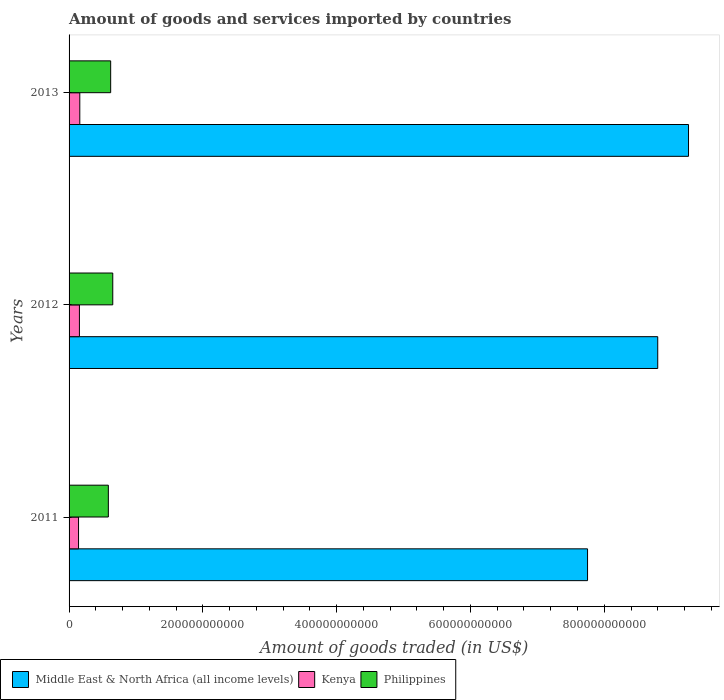How many different coloured bars are there?
Your response must be concise. 3. How many bars are there on the 3rd tick from the bottom?
Your answer should be very brief. 3. What is the label of the 3rd group of bars from the top?
Give a very brief answer. 2011. In how many cases, is the number of bars for a given year not equal to the number of legend labels?
Your answer should be very brief. 0. What is the total amount of goods and services imported in Philippines in 2011?
Provide a succinct answer. 5.87e+1. Across all years, what is the maximum total amount of goods and services imported in Middle East & North Africa (all income levels)?
Your answer should be compact. 9.26e+11. Across all years, what is the minimum total amount of goods and services imported in Kenya?
Provide a succinct answer. 1.42e+1. In which year was the total amount of goods and services imported in Kenya maximum?
Your response must be concise. 2013. What is the total total amount of goods and services imported in Kenya in the graph?
Offer a very short reply. 4.57e+1. What is the difference between the total amount of goods and services imported in Kenya in 2011 and that in 2012?
Make the answer very short. -1.31e+09. What is the difference between the total amount of goods and services imported in Philippines in 2011 and the total amount of goods and services imported in Kenya in 2013?
Offer a terse response. 4.27e+1. What is the average total amount of goods and services imported in Kenya per year?
Your response must be concise. 1.52e+1. In the year 2013, what is the difference between the total amount of goods and services imported in Middle East & North Africa (all income levels) and total amount of goods and services imported in Kenya?
Offer a terse response. 9.10e+11. In how many years, is the total amount of goods and services imported in Middle East & North Africa (all income levels) greater than 720000000000 US$?
Your response must be concise. 3. What is the ratio of the total amount of goods and services imported in Kenya in 2011 to that in 2013?
Offer a very short reply. 0.88. Is the difference between the total amount of goods and services imported in Middle East & North Africa (all income levels) in 2012 and 2013 greater than the difference between the total amount of goods and services imported in Kenya in 2012 and 2013?
Make the answer very short. No. What is the difference between the highest and the second highest total amount of goods and services imported in Middle East & North Africa (all income levels)?
Provide a succinct answer. 4.60e+1. What is the difference between the highest and the lowest total amount of goods and services imported in Middle East & North Africa (all income levels)?
Give a very brief answer. 1.51e+11. Is the sum of the total amount of goods and services imported in Middle East & North Africa (all income levels) in 2012 and 2013 greater than the maximum total amount of goods and services imported in Kenya across all years?
Provide a short and direct response. Yes. What does the 2nd bar from the bottom in 2013 represents?
Offer a terse response. Kenya. How many years are there in the graph?
Make the answer very short. 3. What is the difference between two consecutive major ticks on the X-axis?
Offer a very short reply. 2.00e+11. Does the graph contain grids?
Your answer should be very brief. No. Where does the legend appear in the graph?
Ensure brevity in your answer.  Bottom left. How many legend labels are there?
Keep it short and to the point. 3. How are the legend labels stacked?
Your response must be concise. Horizontal. What is the title of the graph?
Provide a short and direct response. Amount of goods and services imported by countries. Does "Kuwait" appear as one of the legend labels in the graph?
Provide a short and direct response. No. What is the label or title of the X-axis?
Give a very brief answer. Amount of goods traded (in US$). What is the Amount of goods traded (in US$) in Middle East & North Africa (all income levels) in 2011?
Offer a very short reply. 7.75e+11. What is the Amount of goods traded (in US$) of Kenya in 2011?
Your response must be concise. 1.42e+1. What is the Amount of goods traded (in US$) in Philippines in 2011?
Provide a succinct answer. 5.87e+1. What is the Amount of goods traded (in US$) in Middle East & North Africa (all income levels) in 2012?
Provide a succinct answer. 8.80e+11. What is the Amount of goods traded (in US$) of Kenya in 2012?
Your answer should be compact. 1.55e+1. What is the Amount of goods traded (in US$) in Philippines in 2012?
Provide a succinct answer. 6.53e+1. What is the Amount of goods traded (in US$) in Middle East & North Africa (all income levels) in 2013?
Keep it short and to the point. 9.26e+11. What is the Amount of goods traded (in US$) in Kenya in 2013?
Offer a terse response. 1.60e+1. What is the Amount of goods traded (in US$) of Philippines in 2013?
Offer a terse response. 6.22e+1. Across all years, what is the maximum Amount of goods traded (in US$) of Middle East & North Africa (all income levels)?
Give a very brief answer. 9.26e+11. Across all years, what is the maximum Amount of goods traded (in US$) of Kenya?
Keep it short and to the point. 1.60e+1. Across all years, what is the maximum Amount of goods traded (in US$) in Philippines?
Offer a very short reply. 6.53e+1. Across all years, what is the minimum Amount of goods traded (in US$) of Middle East & North Africa (all income levels)?
Make the answer very short. 7.75e+11. Across all years, what is the minimum Amount of goods traded (in US$) in Kenya?
Ensure brevity in your answer.  1.42e+1. Across all years, what is the minimum Amount of goods traded (in US$) of Philippines?
Your response must be concise. 5.87e+1. What is the total Amount of goods traded (in US$) of Middle East & North Africa (all income levels) in the graph?
Provide a short and direct response. 2.58e+12. What is the total Amount of goods traded (in US$) of Kenya in the graph?
Provide a short and direct response. 4.57e+1. What is the total Amount of goods traded (in US$) in Philippines in the graph?
Provide a succinct answer. 1.86e+11. What is the difference between the Amount of goods traded (in US$) of Middle East & North Africa (all income levels) in 2011 and that in 2012?
Provide a succinct answer. -1.05e+11. What is the difference between the Amount of goods traded (in US$) of Kenya in 2011 and that in 2012?
Your answer should be very brief. -1.31e+09. What is the difference between the Amount of goods traded (in US$) in Philippines in 2011 and that in 2012?
Offer a terse response. -6.61e+09. What is the difference between the Amount of goods traded (in US$) in Middle East & North Africa (all income levels) in 2011 and that in 2013?
Offer a terse response. -1.51e+11. What is the difference between the Amount of goods traded (in US$) in Kenya in 2011 and that in 2013?
Give a very brief answer. -1.86e+09. What is the difference between the Amount of goods traded (in US$) in Philippines in 2011 and that in 2013?
Your answer should be very brief. -3.47e+09. What is the difference between the Amount of goods traded (in US$) in Middle East & North Africa (all income levels) in 2012 and that in 2013?
Keep it short and to the point. -4.60e+1. What is the difference between the Amount of goods traded (in US$) of Kenya in 2012 and that in 2013?
Ensure brevity in your answer.  -5.52e+08. What is the difference between the Amount of goods traded (in US$) of Philippines in 2012 and that in 2013?
Make the answer very short. 3.14e+09. What is the difference between the Amount of goods traded (in US$) of Middle East & North Africa (all income levels) in 2011 and the Amount of goods traded (in US$) of Kenya in 2012?
Give a very brief answer. 7.60e+11. What is the difference between the Amount of goods traded (in US$) in Middle East & North Africa (all income levels) in 2011 and the Amount of goods traded (in US$) in Philippines in 2012?
Provide a short and direct response. 7.10e+11. What is the difference between the Amount of goods traded (in US$) of Kenya in 2011 and the Amount of goods traded (in US$) of Philippines in 2012?
Provide a succinct answer. -5.11e+1. What is the difference between the Amount of goods traded (in US$) of Middle East & North Africa (all income levels) in 2011 and the Amount of goods traded (in US$) of Kenya in 2013?
Make the answer very short. 7.59e+11. What is the difference between the Amount of goods traded (in US$) of Middle East & North Africa (all income levels) in 2011 and the Amount of goods traded (in US$) of Philippines in 2013?
Ensure brevity in your answer.  7.13e+11. What is the difference between the Amount of goods traded (in US$) in Kenya in 2011 and the Amount of goods traded (in US$) in Philippines in 2013?
Provide a succinct answer. -4.80e+1. What is the difference between the Amount of goods traded (in US$) of Middle East & North Africa (all income levels) in 2012 and the Amount of goods traded (in US$) of Kenya in 2013?
Offer a terse response. 8.64e+11. What is the difference between the Amount of goods traded (in US$) in Middle East & North Africa (all income levels) in 2012 and the Amount of goods traded (in US$) in Philippines in 2013?
Offer a very short reply. 8.18e+11. What is the difference between the Amount of goods traded (in US$) in Kenya in 2012 and the Amount of goods traded (in US$) in Philippines in 2013?
Provide a short and direct response. -4.67e+1. What is the average Amount of goods traded (in US$) of Middle East & North Africa (all income levels) per year?
Give a very brief answer. 8.60e+11. What is the average Amount of goods traded (in US$) in Kenya per year?
Provide a short and direct response. 1.52e+1. What is the average Amount of goods traded (in US$) in Philippines per year?
Offer a very short reply. 6.21e+1. In the year 2011, what is the difference between the Amount of goods traded (in US$) of Middle East & North Africa (all income levels) and Amount of goods traded (in US$) of Kenya?
Offer a terse response. 7.61e+11. In the year 2011, what is the difference between the Amount of goods traded (in US$) in Middle East & North Africa (all income levels) and Amount of goods traded (in US$) in Philippines?
Provide a succinct answer. 7.16e+11. In the year 2011, what is the difference between the Amount of goods traded (in US$) in Kenya and Amount of goods traded (in US$) in Philippines?
Ensure brevity in your answer.  -4.45e+1. In the year 2012, what is the difference between the Amount of goods traded (in US$) in Middle East & North Africa (all income levels) and Amount of goods traded (in US$) in Kenya?
Offer a very short reply. 8.64e+11. In the year 2012, what is the difference between the Amount of goods traded (in US$) in Middle East & North Africa (all income levels) and Amount of goods traded (in US$) in Philippines?
Give a very brief answer. 8.15e+11. In the year 2012, what is the difference between the Amount of goods traded (in US$) in Kenya and Amount of goods traded (in US$) in Philippines?
Make the answer very short. -4.98e+1. In the year 2013, what is the difference between the Amount of goods traded (in US$) in Middle East & North Africa (all income levels) and Amount of goods traded (in US$) in Kenya?
Provide a succinct answer. 9.10e+11. In the year 2013, what is the difference between the Amount of goods traded (in US$) of Middle East & North Africa (all income levels) and Amount of goods traded (in US$) of Philippines?
Your response must be concise. 8.64e+11. In the year 2013, what is the difference between the Amount of goods traded (in US$) of Kenya and Amount of goods traded (in US$) of Philippines?
Your answer should be very brief. -4.62e+1. What is the ratio of the Amount of goods traded (in US$) in Middle East & North Africa (all income levels) in 2011 to that in 2012?
Offer a very short reply. 0.88. What is the ratio of the Amount of goods traded (in US$) in Kenya in 2011 to that in 2012?
Give a very brief answer. 0.92. What is the ratio of the Amount of goods traded (in US$) of Philippines in 2011 to that in 2012?
Your answer should be compact. 0.9. What is the ratio of the Amount of goods traded (in US$) of Middle East & North Africa (all income levels) in 2011 to that in 2013?
Offer a very short reply. 0.84. What is the ratio of the Amount of goods traded (in US$) in Kenya in 2011 to that in 2013?
Make the answer very short. 0.88. What is the ratio of the Amount of goods traded (in US$) in Philippines in 2011 to that in 2013?
Offer a terse response. 0.94. What is the ratio of the Amount of goods traded (in US$) of Middle East & North Africa (all income levels) in 2012 to that in 2013?
Keep it short and to the point. 0.95. What is the ratio of the Amount of goods traded (in US$) of Kenya in 2012 to that in 2013?
Provide a short and direct response. 0.97. What is the ratio of the Amount of goods traded (in US$) in Philippines in 2012 to that in 2013?
Your answer should be compact. 1.05. What is the difference between the highest and the second highest Amount of goods traded (in US$) of Middle East & North Africa (all income levels)?
Make the answer very short. 4.60e+1. What is the difference between the highest and the second highest Amount of goods traded (in US$) of Kenya?
Offer a terse response. 5.52e+08. What is the difference between the highest and the second highest Amount of goods traded (in US$) in Philippines?
Provide a short and direct response. 3.14e+09. What is the difference between the highest and the lowest Amount of goods traded (in US$) of Middle East & North Africa (all income levels)?
Provide a short and direct response. 1.51e+11. What is the difference between the highest and the lowest Amount of goods traded (in US$) of Kenya?
Provide a short and direct response. 1.86e+09. What is the difference between the highest and the lowest Amount of goods traded (in US$) in Philippines?
Give a very brief answer. 6.61e+09. 